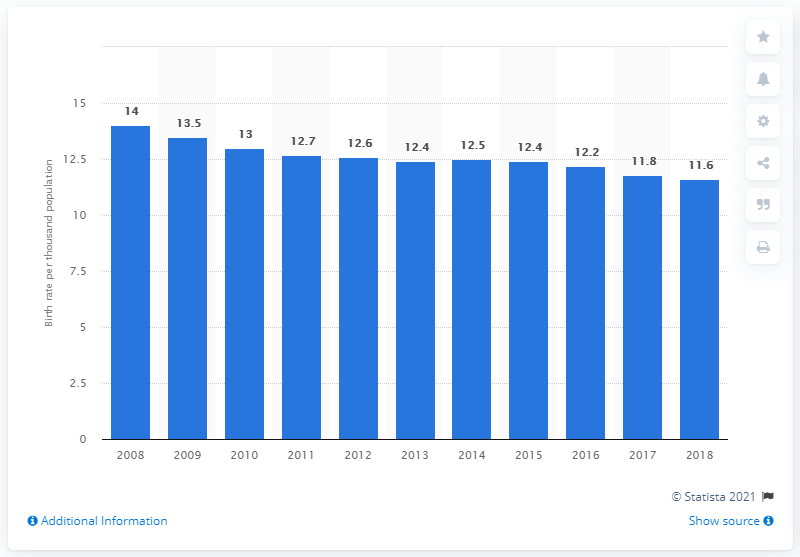Specify some key components in this picture. According to data from 2018, the crude birth rate in the United States was 11.6. 